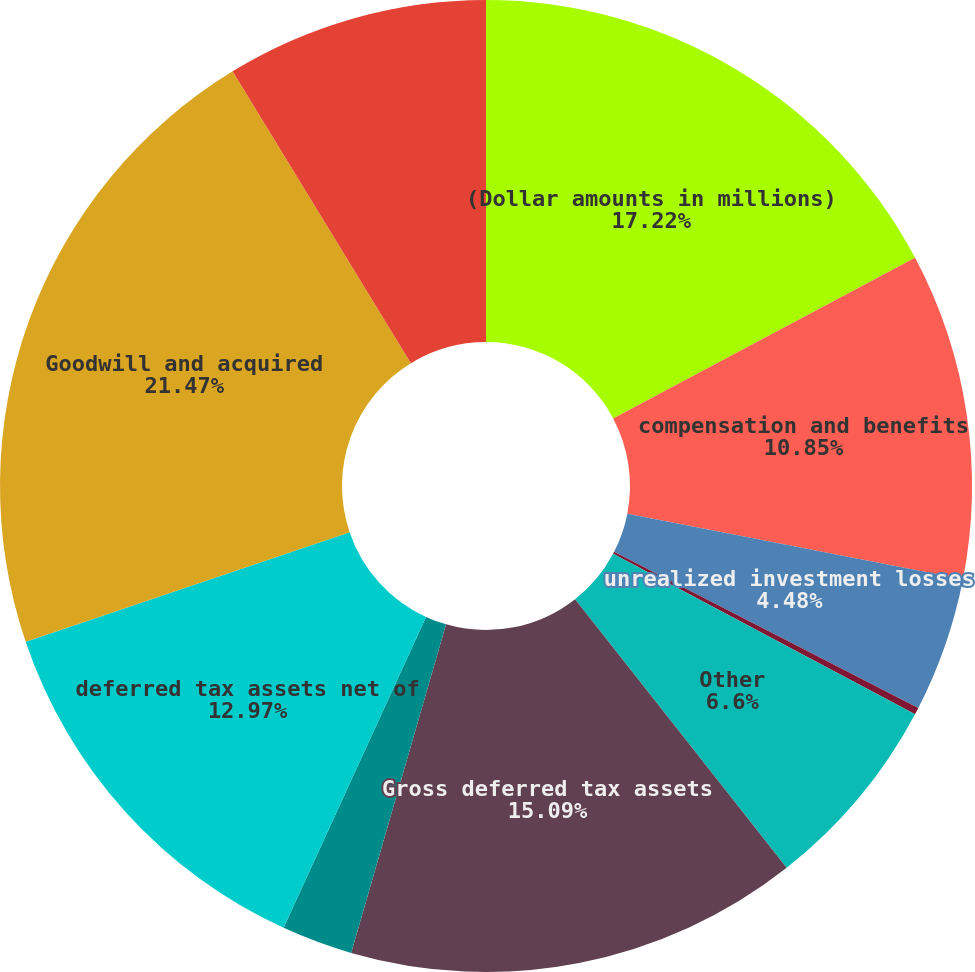Convert chart. <chart><loc_0><loc_0><loc_500><loc_500><pie_chart><fcel>(Dollar amounts in millions)<fcel>compensation and benefits<fcel>unrealized investment losses<fcel>loss carryforwards<fcel>Other<fcel>Gross deferred tax assets<fcel>less deferred tax valuation<fcel>deferred tax assets net of<fcel>Goodwill and acquired<fcel>acquired finite-lived<nl><fcel>17.22%<fcel>10.85%<fcel>4.48%<fcel>0.23%<fcel>6.6%<fcel>15.09%<fcel>2.36%<fcel>12.97%<fcel>21.46%<fcel>8.73%<nl></chart> 